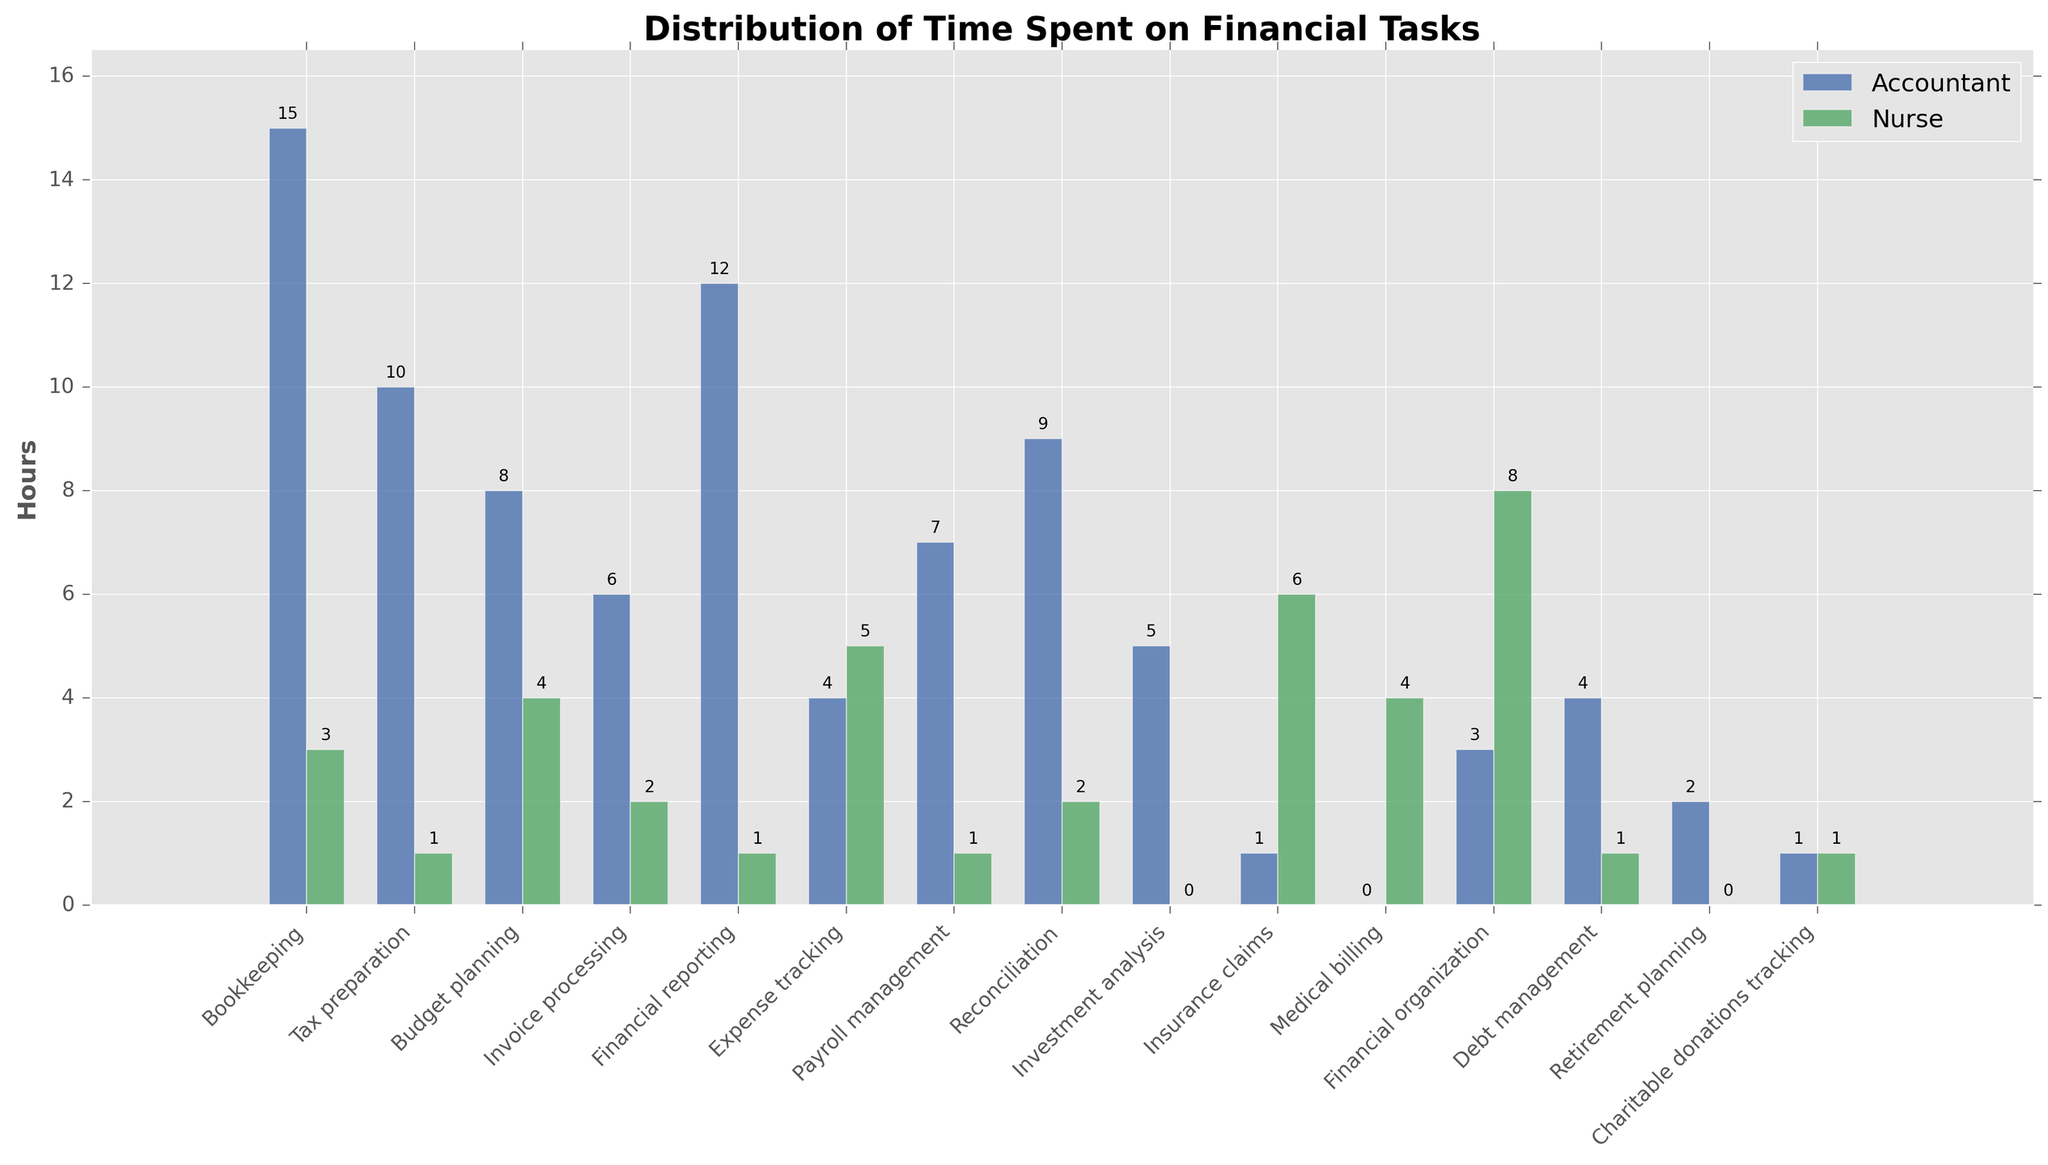Which task do nurses spend the most time on? From the bar chart, observe the height of the green bars representing nurses. The task with the tallest green bar indicates the maximum time spent. The highest bar corresponds to "Financial organization" with 8 hours.
Answer: Financial organization Which task has the greatest difference in time spent between accountants and nurses? Find the task where the difference in bar heights between blue (accountant) and green (nurse) is largest. For "Bookkeeping," accountants spend 15 hours, whereas nurses spend 3 hours, giving a difference of 12 hours. This is the largest difference.
Answer: Bookkeeping What is the total time spent by accountants on "Budget planning" and "Financial reporting"? From the chart, accountant hours for "Budget planning" are 8, and for "Financial reporting" are 12. Sum these values: 8 + 12 = 20 hours.
Answer: 20 hours On how many tasks do nurses spend more time than accountants? Compare the height of bars for nurses (green) with accountants (blue) for each task. Nurses spend more time than accountants on "Expense tracking," "Insurance claims," "Medical billing," and "Financial organization." This gives 4 tasks.
Answer: 4 For which task do both accountants and nurses spend equal time? Check the bars where blue and green bars are of equal height. For "Charitable donations tracking," both spend 1 hour.
Answer: Charitable donations tracking Which task do accountants spend the least amount of time on? Look for the shortest blue bar in the chart. The shortest bar is for "Insurance claims" and "Medical billing," each at 1 hour.
Answer: Insurance claims and Medical billing What is the average time accountants spend on "Bookkeeping," "Tax preparation," and "Budget planning"? Accountant hours for "Bookkeeping" is 15, "Tax preparation" is 10, and "Budget planning" is 8. Sum these values (15 + 10 + 8 = 33) and then divide by 3 (33/3 = 11).
Answer: 11 hours How much more time do accountants spend on "Payroll management" compared to nurses? Accountants spend 7 hours on "Payroll management," while nurses spend 1 hour. The difference is 7 - 1 = 6 hours.
Answer: 6 hours Which visual attribute distinguishes more time spent by accountants on "Bookkeeping" compared to nurses? Observe the height of the bars. The blue bar for accountants is much taller than the green bar for nurses in "Bookkeeping." This indicates more time spent by accountants.
Answer: Height of the blue bar How does the time spent by nurses on "Medical billing" compare to that by accountants? Nurses spend 4 hours on "Medical billing," while accountants spend 0 hours. This indicates nurses spend more time.
Answer: Nurses spend more time 